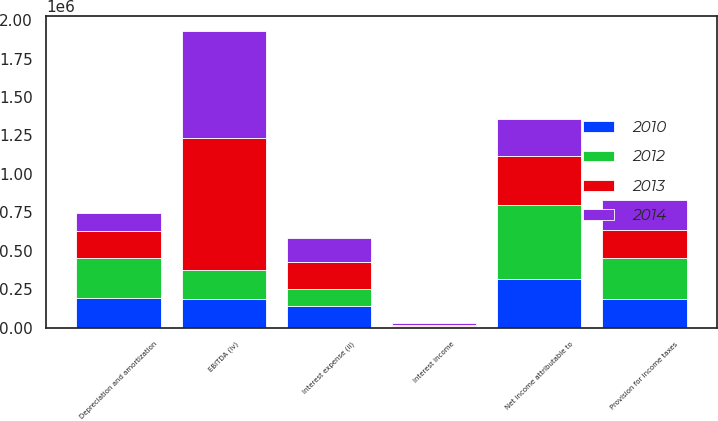<chart> <loc_0><loc_0><loc_500><loc_500><stacked_bar_chart><ecel><fcel>Net income attributable to<fcel>Depreciation and amortization<fcel>Interest expense (ii)<fcel>Provision for income taxes<fcel>Interest income<fcel>EBITDA (iv)<nl><fcel>2012<fcel>484503<fcel>265101<fcel>112035<fcel>263759<fcel>6233<fcel>187447<nl><fcel>2010<fcel>316538<fcel>191270<fcel>138379<fcel>188561<fcel>6289<fcel>187447<nl><fcel>2013<fcel>315555<fcel>170905<fcel>176649<fcel>186333<fcel>7647<fcel>861621<nl><fcel>2014<fcel>239162<fcel>116930<fcel>153497<fcel>193115<fcel>9443<fcel>693261<nl></chart> 